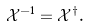Convert formula to latex. <formula><loc_0><loc_0><loc_500><loc_500>\mathcal { X } ^ { - 1 } = \mathcal { X } ^ { \dagger } .</formula> 